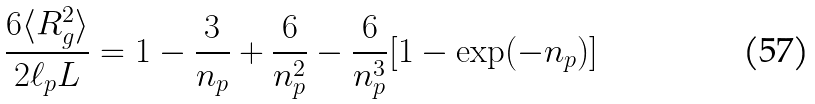<formula> <loc_0><loc_0><loc_500><loc_500>\frac { 6 \langle R _ { g } ^ { 2 } \rangle } { 2 \ell _ { p } L } = 1 - \frac { 3 } { n _ { p } } + \frac { 6 } { n _ { p } ^ { 2 } } - \frac { 6 } { n _ { p } ^ { 3 } } [ 1 - \exp ( - n _ { p } ) ]</formula> 